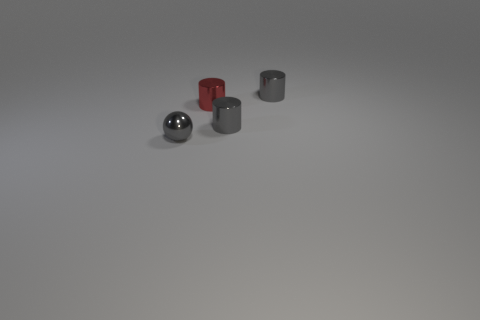Subtract all gray cylinders. How many cylinders are left? 1 Add 4 red shiny cylinders. How many objects exist? 8 Subtract all yellow blocks. How many gray cylinders are left? 2 Subtract all gray cylinders. How many cylinders are left? 1 Subtract all balls. How many objects are left? 3 Subtract all green balls. Subtract all blue cylinders. How many balls are left? 1 Subtract all large purple metallic things. Subtract all metallic objects. How many objects are left? 0 Add 2 tiny metallic spheres. How many tiny metallic spheres are left? 3 Add 1 small balls. How many small balls exist? 2 Subtract 0 purple cubes. How many objects are left? 4 